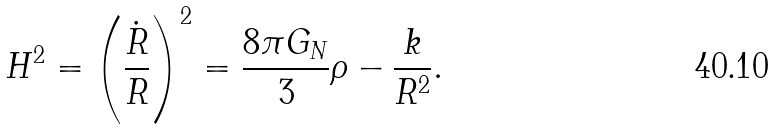<formula> <loc_0><loc_0><loc_500><loc_500>H ^ { 2 } = \left ( \frac { \dot { R } } { R } \right ) ^ { 2 } = \frac { 8 \pi G _ { N } } { 3 } \rho - \frac { k } { R ^ { 2 } } .</formula> 